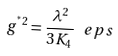Convert formula to latex. <formula><loc_0><loc_0><loc_500><loc_500>g ^ { ^ { * } 2 } = \frac { \lambda ^ { 2 } } { 3 K _ { 4 } } \, \ e p s</formula> 